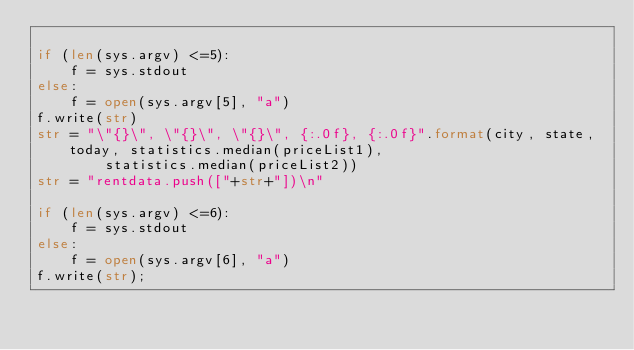Convert code to text. <code><loc_0><loc_0><loc_500><loc_500><_Python_>
if (len(sys.argv) <=5):
    f = sys.stdout
else:
    f = open(sys.argv[5], "a")
f.write(str)
str = "\"{}\", \"{}\", \"{}\", {:.0f}, {:.0f}".format(city, state, today, statistics.median(priceList1),
        statistics.median(priceList2))
str = "rentdata.push(["+str+"])\n"

if (len(sys.argv) <=6):
    f = sys.stdout
else:
    f = open(sys.argv[6], "a")
f.write(str);
</code> 